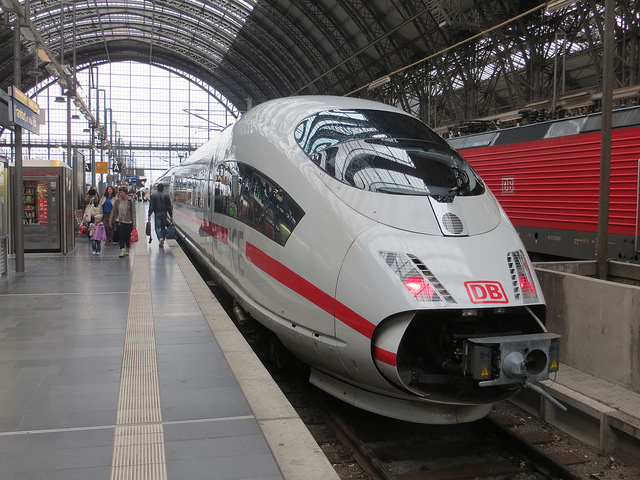Identify and read out the text in this image. DB 